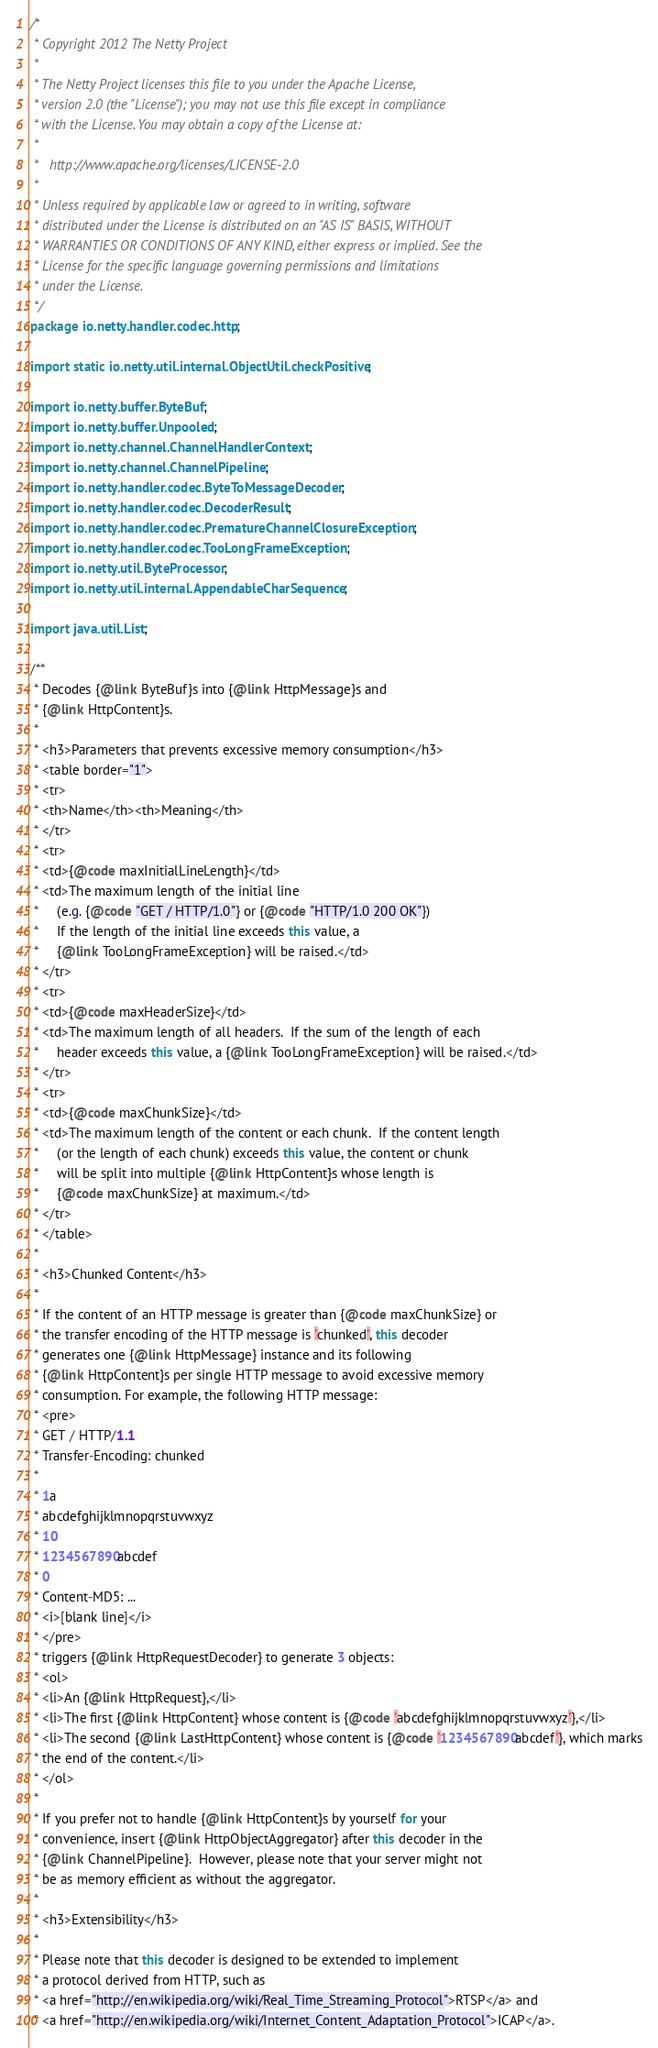Convert code to text. <code><loc_0><loc_0><loc_500><loc_500><_Java_>/*
 * Copyright 2012 The Netty Project
 *
 * The Netty Project licenses this file to you under the Apache License,
 * version 2.0 (the "License"); you may not use this file except in compliance
 * with the License. You may obtain a copy of the License at:
 *
 *   http://www.apache.org/licenses/LICENSE-2.0
 *
 * Unless required by applicable law or agreed to in writing, software
 * distributed under the License is distributed on an "AS IS" BASIS, WITHOUT
 * WARRANTIES OR CONDITIONS OF ANY KIND, either express or implied. See the
 * License for the specific language governing permissions and limitations
 * under the License.
 */
package io.netty.handler.codec.http;

import static io.netty.util.internal.ObjectUtil.checkPositive;

import io.netty.buffer.ByteBuf;
import io.netty.buffer.Unpooled;
import io.netty.channel.ChannelHandlerContext;
import io.netty.channel.ChannelPipeline;
import io.netty.handler.codec.ByteToMessageDecoder;
import io.netty.handler.codec.DecoderResult;
import io.netty.handler.codec.PrematureChannelClosureException;
import io.netty.handler.codec.TooLongFrameException;
import io.netty.util.ByteProcessor;
import io.netty.util.internal.AppendableCharSequence;

import java.util.List;

/**
 * Decodes {@link ByteBuf}s into {@link HttpMessage}s and
 * {@link HttpContent}s.
 *
 * <h3>Parameters that prevents excessive memory consumption</h3>
 * <table border="1">
 * <tr>
 * <th>Name</th><th>Meaning</th>
 * </tr>
 * <tr>
 * <td>{@code maxInitialLineLength}</td>
 * <td>The maximum length of the initial line
 *     (e.g. {@code "GET / HTTP/1.0"} or {@code "HTTP/1.0 200 OK"})
 *     If the length of the initial line exceeds this value, a
 *     {@link TooLongFrameException} will be raised.</td>
 * </tr>
 * <tr>
 * <td>{@code maxHeaderSize}</td>
 * <td>The maximum length of all headers.  If the sum of the length of each
 *     header exceeds this value, a {@link TooLongFrameException} will be raised.</td>
 * </tr>
 * <tr>
 * <td>{@code maxChunkSize}</td>
 * <td>The maximum length of the content or each chunk.  If the content length
 *     (or the length of each chunk) exceeds this value, the content or chunk
 *     will be split into multiple {@link HttpContent}s whose length is
 *     {@code maxChunkSize} at maximum.</td>
 * </tr>
 * </table>
 *
 * <h3>Chunked Content</h3>
 *
 * If the content of an HTTP message is greater than {@code maxChunkSize} or
 * the transfer encoding of the HTTP message is 'chunked', this decoder
 * generates one {@link HttpMessage} instance and its following
 * {@link HttpContent}s per single HTTP message to avoid excessive memory
 * consumption. For example, the following HTTP message:
 * <pre>
 * GET / HTTP/1.1
 * Transfer-Encoding: chunked
 *
 * 1a
 * abcdefghijklmnopqrstuvwxyz
 * 10
 * 1234567890abcdef
 * 0
 * Content-MD5: ...
 * <i>[blank line]</i>
 * </pre>
 * triggers {@link HttpRequestDecoder} to generate 3 objects:
 * <ol>
 * <li>An {@link HttpRequest},</li>
 * <li>The first {@link HttpContent} whose content is {@code 'abcdefghijklmnopqrstuvwxyz'},</li>
 * <li>The second {@link LastHttpContent} whose content is {@code '1234567890abcdef'}, which marks
 * the end of the content.</li>
 * </ol>
 *
 * If you prefer not to handle {@link HttpContent}s by yourself for your
 * convenience, insert {@link HttpObjectAggregator} after this decoder in the
 * {@link ChannelPipeline}.  However, please note that your server might not
 * be as memory efficient as without the aggregator.
 *
 * <h3>Extensibility</h3>
 *
 * Please note that this decoder is designed to be extended to implement
 * a protocol derived from HTTP, such as
 * <a href="http://en.wikipedia.org/wiki/Real_Time_Streaming_Protocol">RTSP</a> and
 * <a href="http://en.wikipedia.org/wiki/Internet_Content_Adaptation_Protocol">ICAP</a>.</code> 